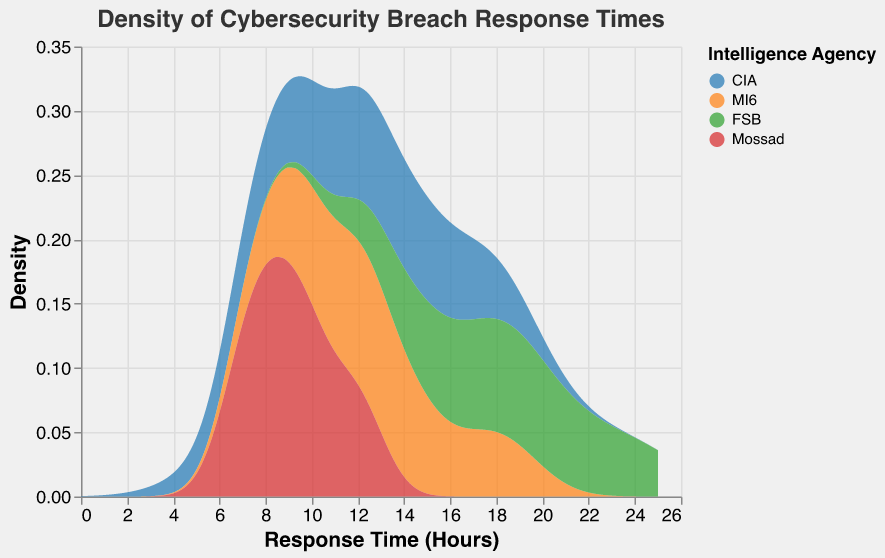Which agency has the most consistent response times? By looking at the density plot, the width of the distribution for each agency indicates the consistency. The agency with the narrowest density curve will show more consistent response times.
Answer: Mossad Which agency has the response time peaked around 12 hours? By inspecting the peaks in the density plot, we can see which agency's density curve has a prominent peak around the 12-hour mark.
Answer: CIA Which agency has the widest range of response times? The agency with the broadest bell-shaped curve on the density plot will have the widest range of response times.
Answer: FSB What is the shape of the response time distribution for MI6? Observing the density plot for the MI6 curve, we can comment on its shape, whether it is symmetrical, skewed, or has multiple peaks.
Answer: Symmetrical, slightly skewed How does the peak response time for Mossad compare with CIA? We need to compare the highest peaks of the density curves for Mossad and CIA.
Answer: Mossad's peak is slightly lower than CIA's Which agency shows the least density at lower response times (less than 10 hours)? By observing the density plot below the 10-hour mark, the curve with the least area under it will represent the agency with the least density at lower response times.
Answer: FSB Between MI6 and Mossad, which agency has a higher density at response times under 10 hours? We must inspect the density curves for MI6 and Mossad below the 10-hour mark to see which one is higher.
Answer: Mossad Which agency has a second peak and around which hours? Check each agency's density plot for a secondary peak and note the hour range for that agency.
Answer: CIA, around 17 hours 